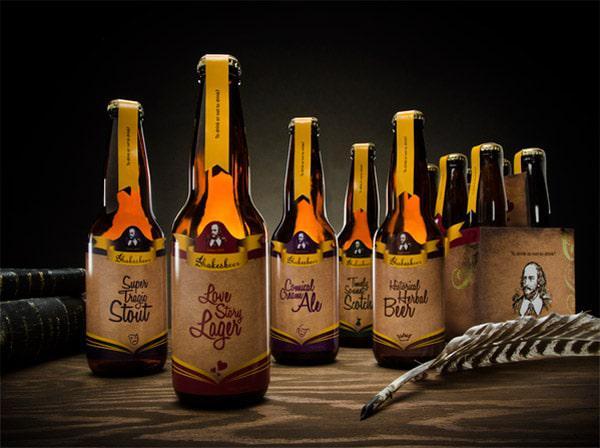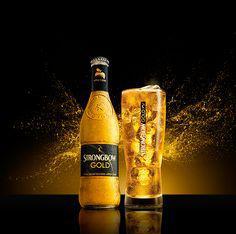The first image is the image on the left, the second image is the image on the right. Evaluate the accuracy of this statement regarding the images: "An image shows the neck of a green bottle.". Is it true? Answer yes or no. No. 